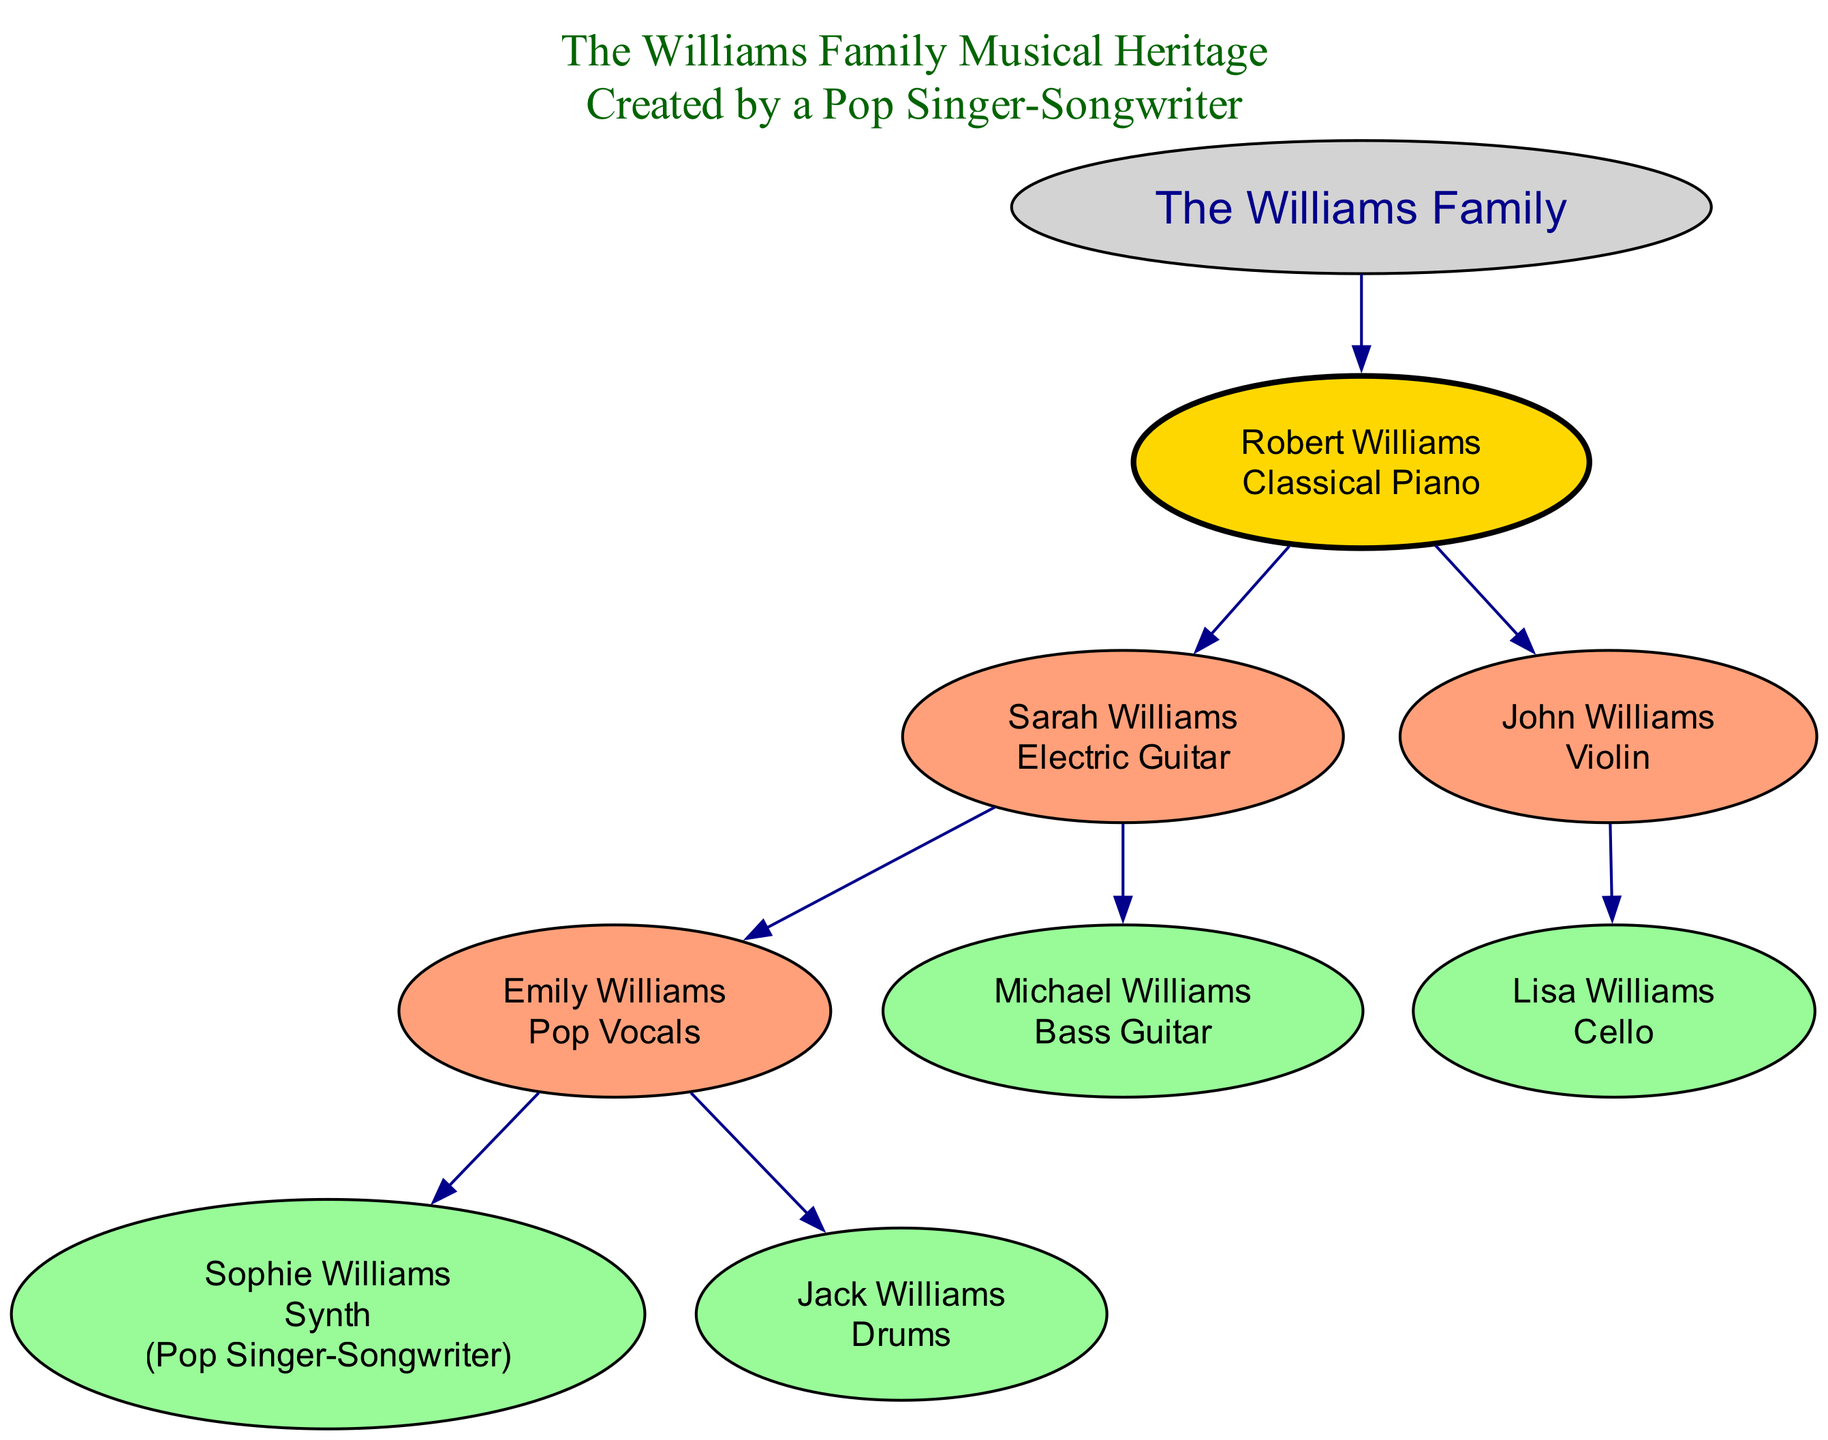What is the instrument played by Robert Williams? The diagram shows that Robert Williams plays the Classical Piano. This information is displayed directly under his name in the family tree.
Answer: Classical Piano How many children does Sarah Williams have? By examining the diagram, we find that Sarah Williams has two children: Emily Williams and Michael Williams. This is clearly laid out in her section of the family tree.
Answer: 2 Who is the pop singer-songwriter in the family? The diagram indicates that Sophie Williams is labeled as a Pop Singer-Songwriter, which is stated alongside her name and instrument in her node.
Answer: Sophie Williams What instrument does John Williams play? Looking at John Williams' section of the family tree, it is evident that he plays the Violin, which is explicitly mentioned within his node.
Answer: Violin Which instrument is played by the youngest generation? The youngest generation includes Sophie Williams (Synth), Jack Williams (Drums), and Lisa Williams (Cello). In order to find the instrument played by this generation, we look at all indicated instruments in their linked nodes. In this case, Synth, Drums, and Cello are played among them.
Answer: Synth, Drums, Cello Who is the parent of Jack Williams? The diagram shows that Jack Williams is the child of Sarah Williams, placing him in the direct lineage that traces back to his mother. This is ascertained by checking the connection from Sarah to Emily and Jack.
Answer: Sarah Williams How many total generations are in the family tree? The family tree contains one root person, Robert Williams, and his children Sarah and John, making it two generations below Robert. Additionally, both Sarah and John have children, creating a total of three generational levels depicted in the diagram.
Answer: 3 What instrument does Emily Williams play? The diagram clearly states that Emily Williams plays Pop Vocals, which is indicated under her name as part of the family tree structure.
Answer: Pop Vocals Who plays the Bass Guitar? According to the diagram, Michael Williams plays the Bass Guitar, which is directly associated with his name in a linked node.
Answer: Michael Williams 